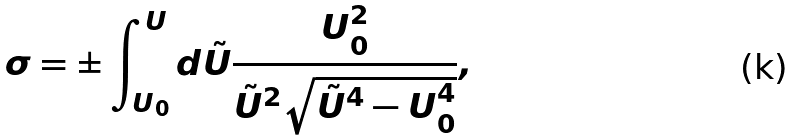Convert formula to latex. <formula><loc_0><loc_0><loc_500><loc_500>\sigma = \pm \int _ { U _ { 0 } } ^ { U } d \tilde { U } \frac { U _ { 0 } ^ { 2 } } { \tilde { U } ^ { 2 } \sqrt { \tilde { U } ^ { 4 } - U _ { 0 } ^ { 4 } } } ,</formula> 